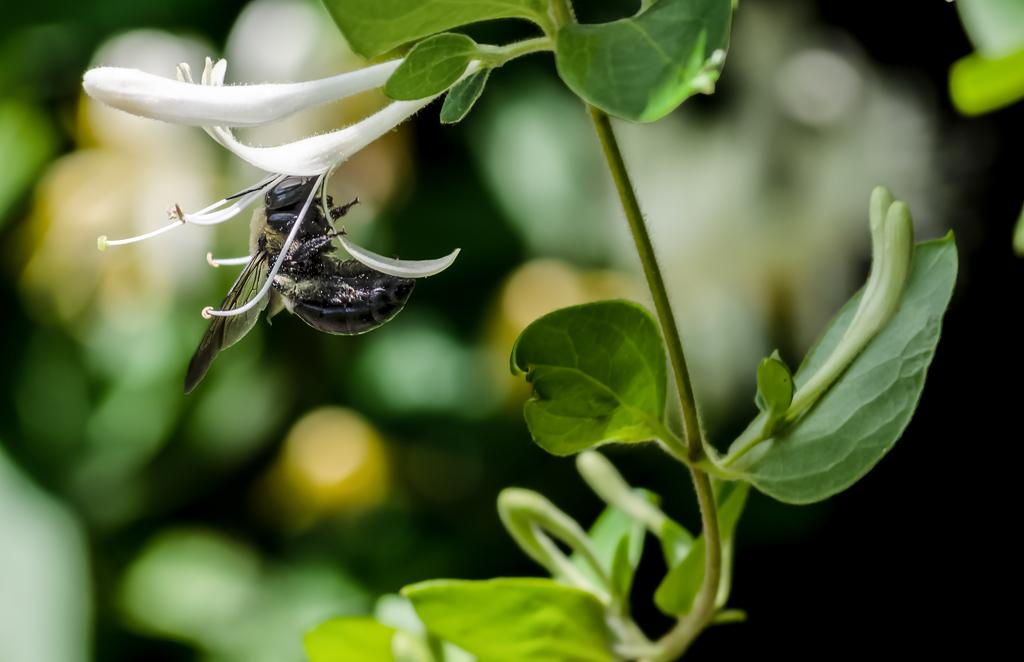What type of plant is in the image? There is a plant in the image, which has leaves, buds, and flowers. Can you describe the plant's features? The plant has leaves, buds, and flowers. Is there any insect present in the image? Yes, there is a fly in the image, and it is black in color. How would you describe the background of the image? The background of the image is blurry. What type of education does the plant receive in the image? Plants do not receive education, as they are living organisms and not capable of learning in the same way humans do. 